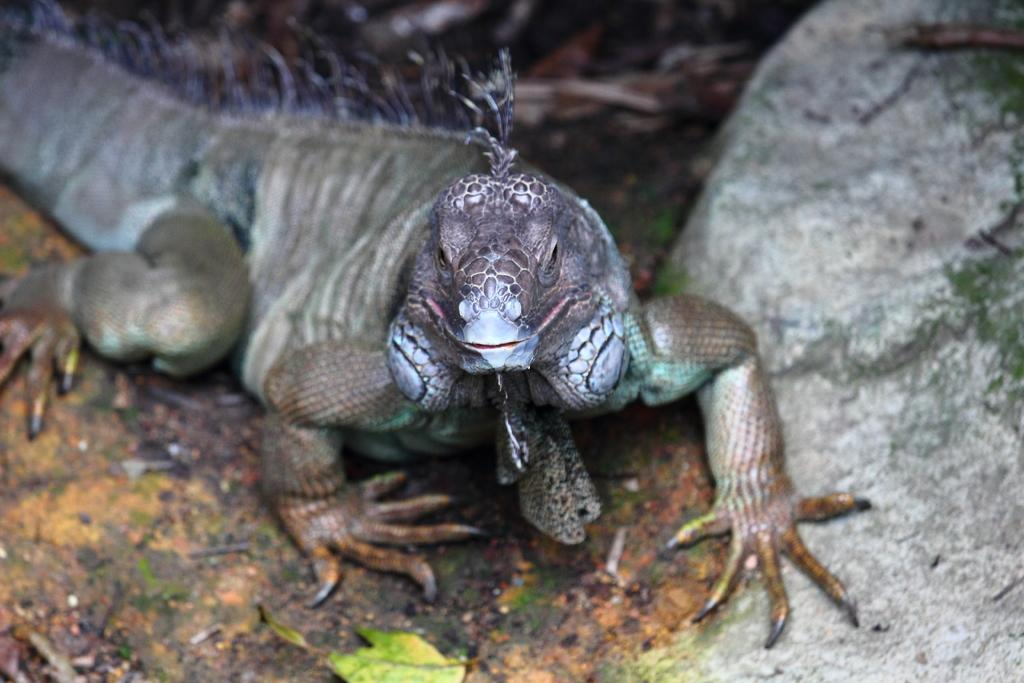What type of animal is in the image? There is a reptile in the image. What colors can be seen on the reptile? The reptile is in ash and brown colors. Where is the reptile located in the image? The reptile is on the ground. What else can be found on the ground in the image? There are leaves on the ground. What other object can be seen on the ground in the image? There is an ash-colored rock in the image. What type of wax is being used to create the scarecrow in the image? There is no scarecrow or wax present in the image; it features a reptile on the ground with leaves and a rock. 